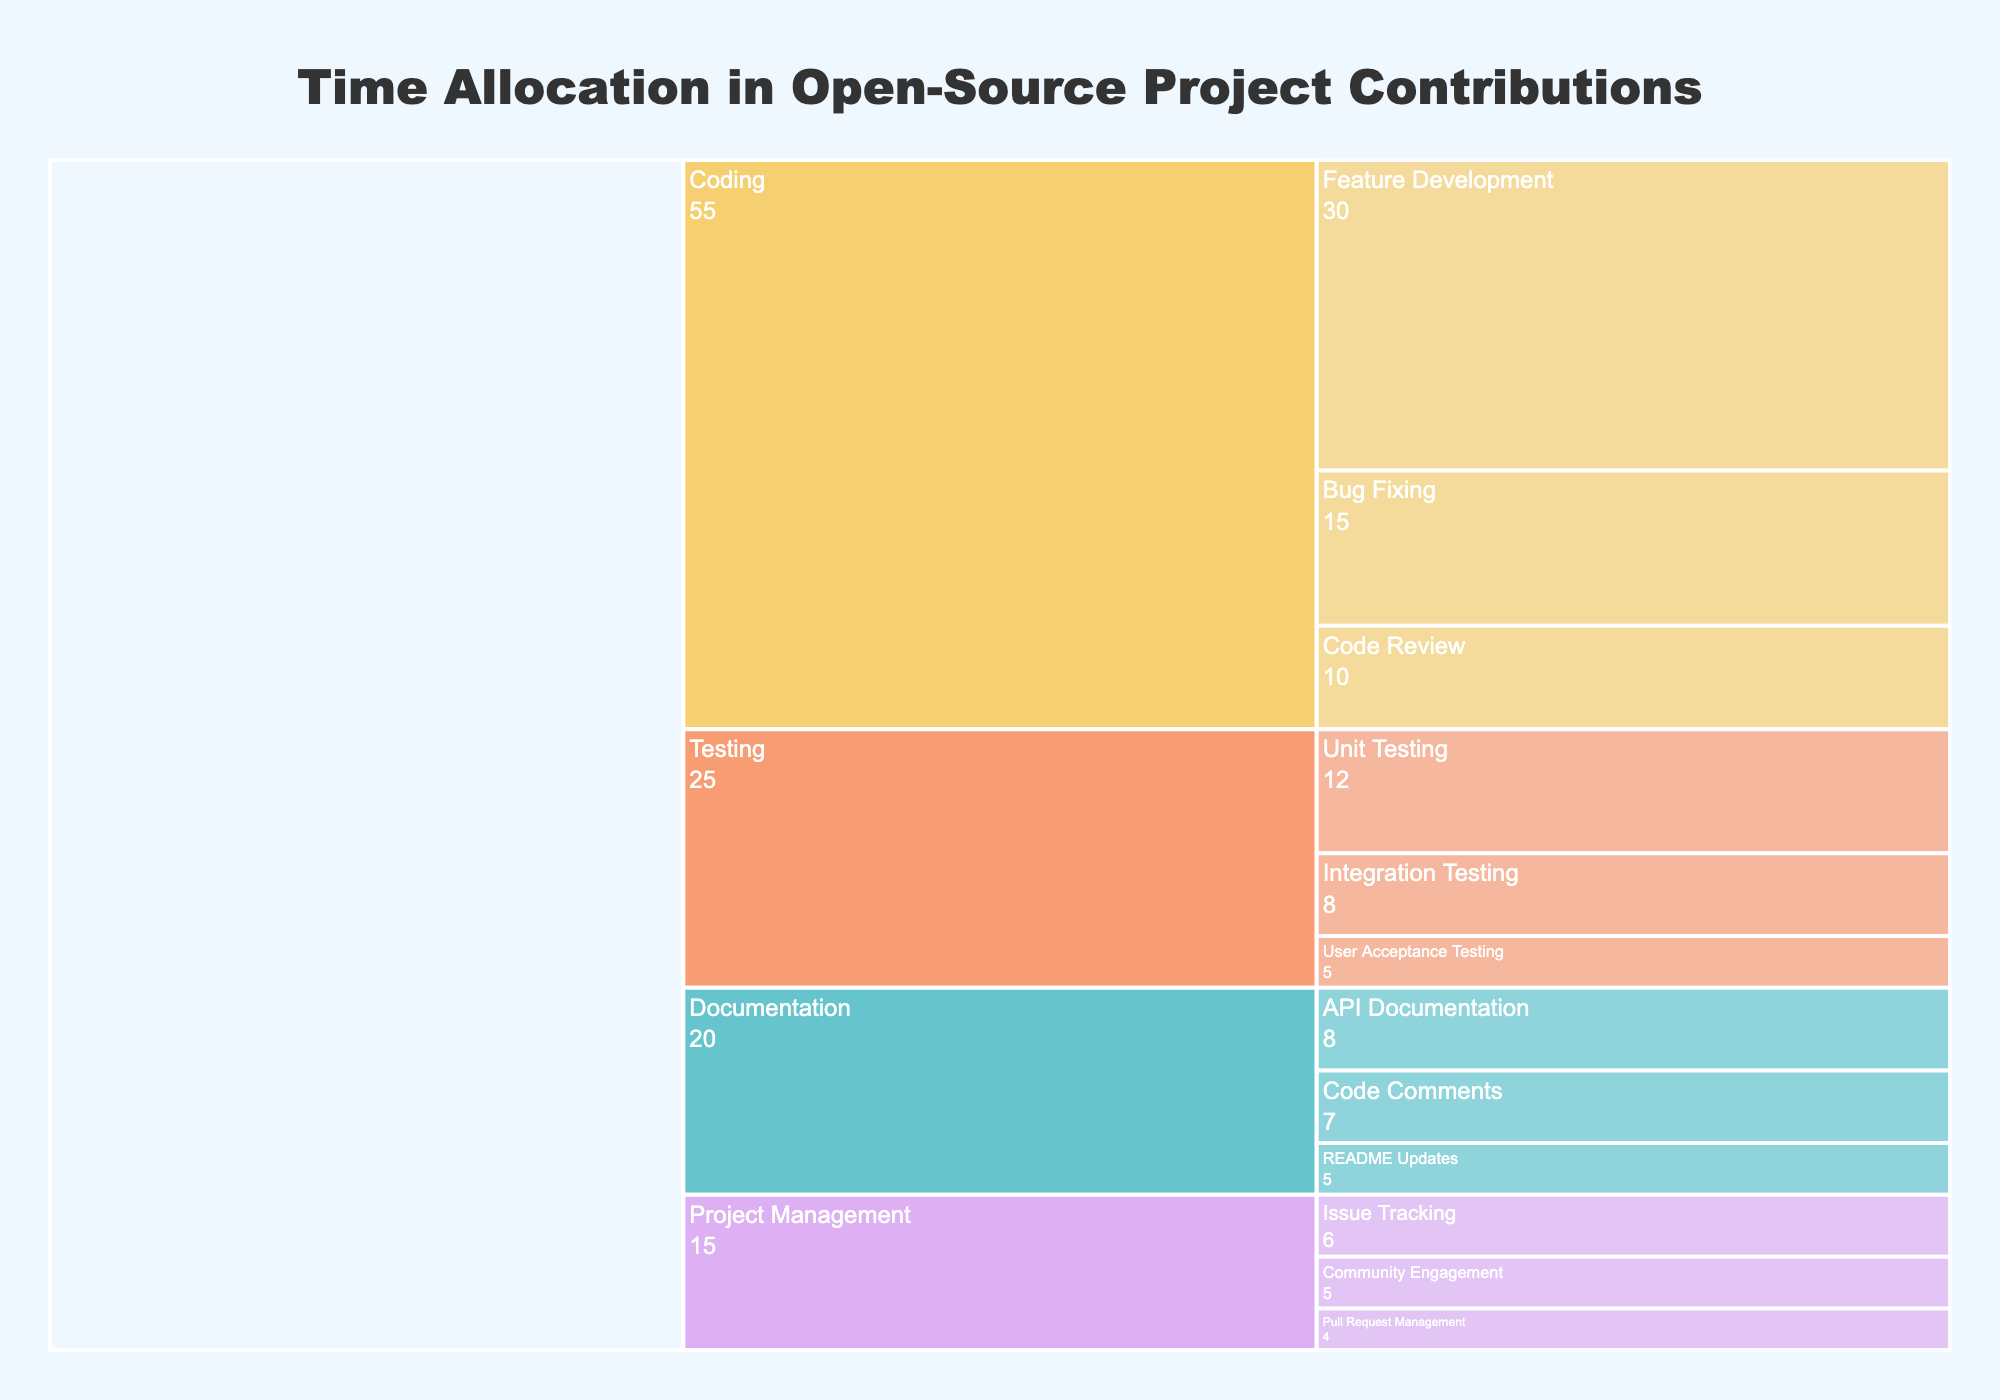What is the title of the icicle chart? The title can be found at the top of the chart. It typically summarizes the visualized data.
Answer: Time Allocation in Open-Source Project Contributions What subphase takes the most time under the Coding phase? Locate the Coding section, then identify which subphase has the largest value next to it.
Answer: Feature Development How much total time is spent on Testing? Sum the time spent on Unit Testing, Integration Testing, and User Acceptance Testing as shown in the Testing section.
Answer: 25 hours Which phase has the least amount of time allocated? Compare the total time for Coding, Testing, Documentation, and Project Management. The smallest number indicates the phase with the least time.
Answer: Project Management Within Project Management, which subphase allocates the most time? Look within the Project Management section and identify the subphase with the largest value.
Answer: Issue Tracking What is the difference in time allocation between Coding and Documentation phases? Subtract the total time for Documentation from the total time for Coding. Coding total: 30 + 15 + 10 = 55. Documentation total: 7 + 5 + 8 = 20. Difference: 55 - 20.
Answer: 35 hours Which phase has a more balanced time allocation across its subphases, Testing or Documentation? Compare the range of time values (max - min) within each phase. Testing ranges from 12 to 5 (range = 7), while Documentation ranges from 8 to 5 (range = 3). Documentation has a smaller range indicating more balance.
Answer: Documentation What is the average time allocation for subphases under Coding? Sum the times for all subphases under Coding, divide by the number of subphases. Sum: 30 + 15 + 10 = 55. Number of subphases: 3. Average: 55 / 3.
Answer: ~18.33 hours Which Testing subphase has the least amount of time allocated? Compare the time values for Unit Testing, Integration Testing, and User Acceptance Testing under the Testing phase.
Answer: User Acceptance Testing 